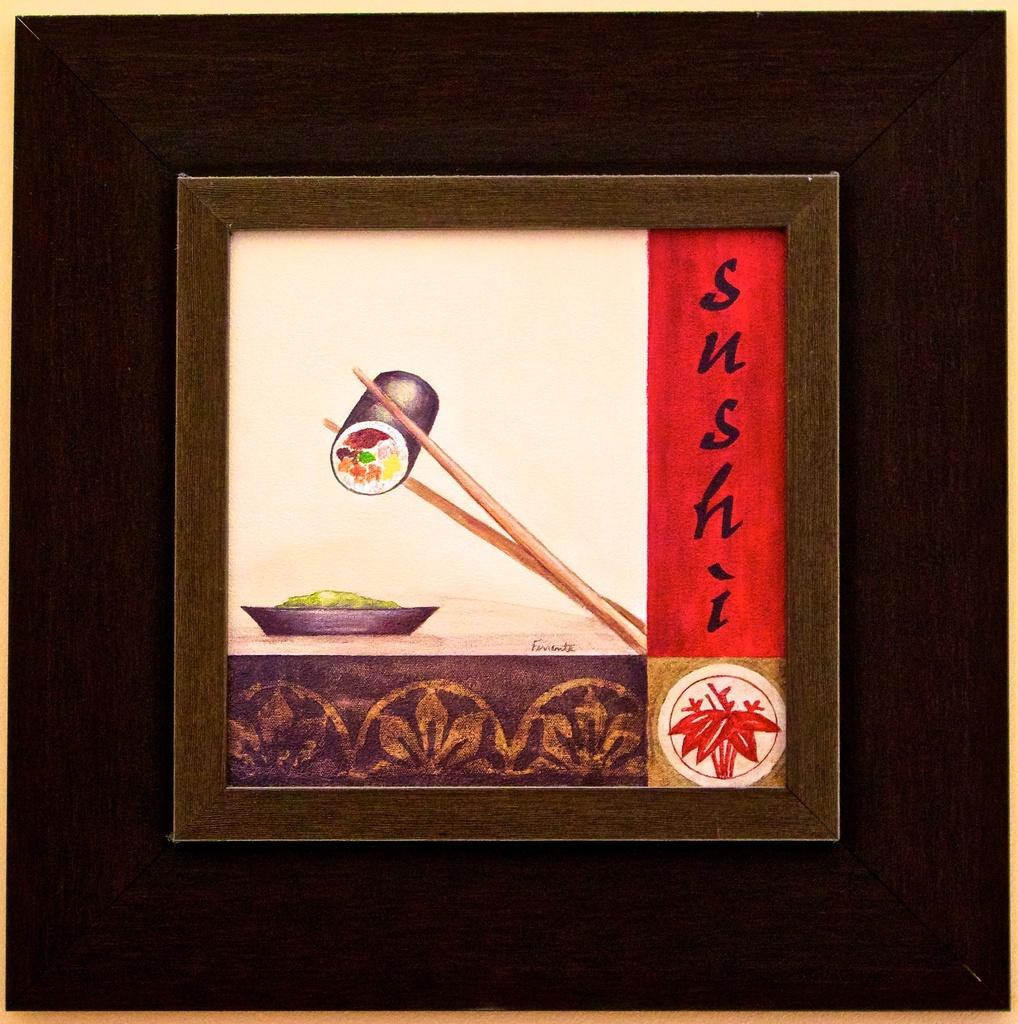Provide a one-sentence caption for the provided image. A framed piece of art with a picture and label of sushi. 